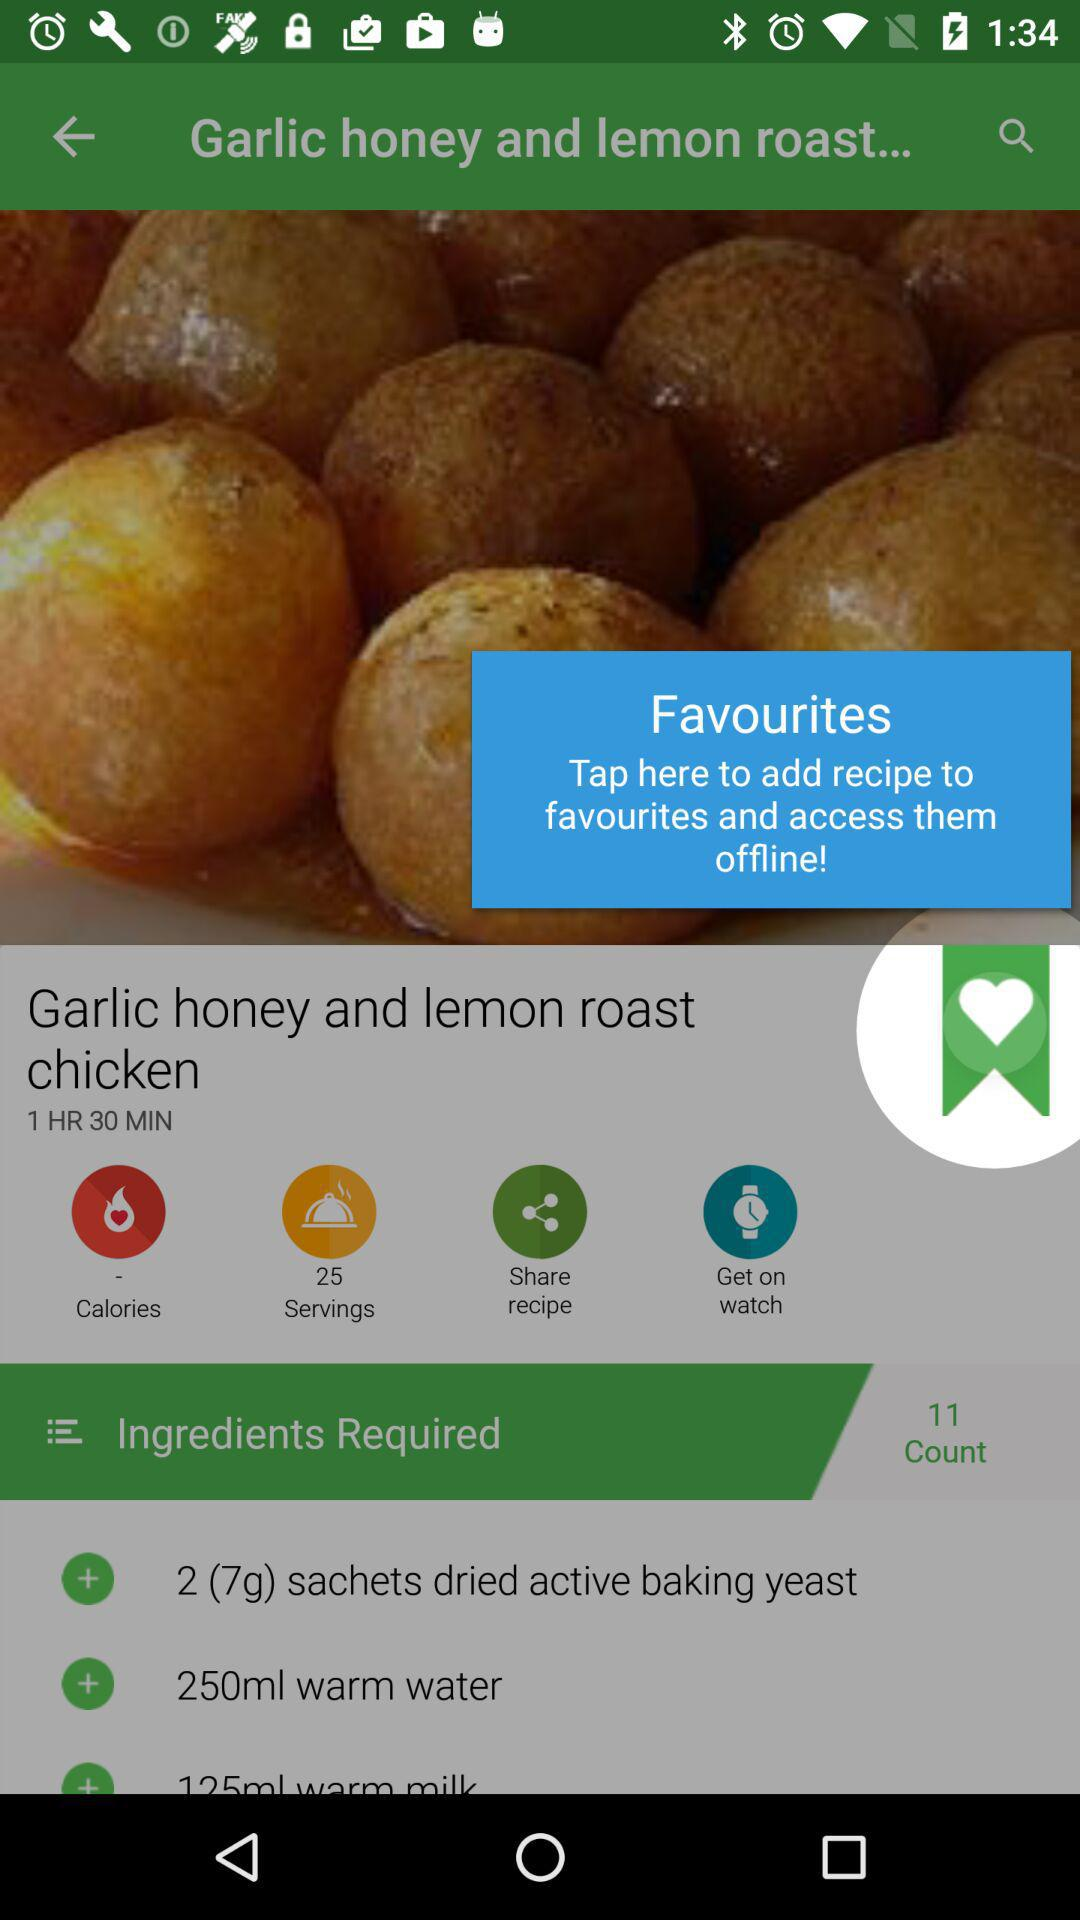How much warm water is required? For the dish, 250 ml of warm water is required. 